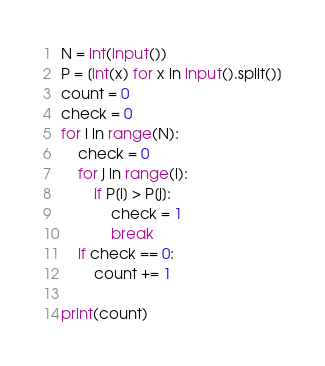Convert code to text. <code><loc_0><loc_0><loc_500><loc_500><_Python_>N = int(input())
P = [int(x) for x in input().split()]
count = 0
check = 0
for i in range(N):
    check = 0
    for j in range(i):
        if P[i] > P[j]:
            check = 1
            break
    if check == 0:
        count += 1

print(count)
</code> 